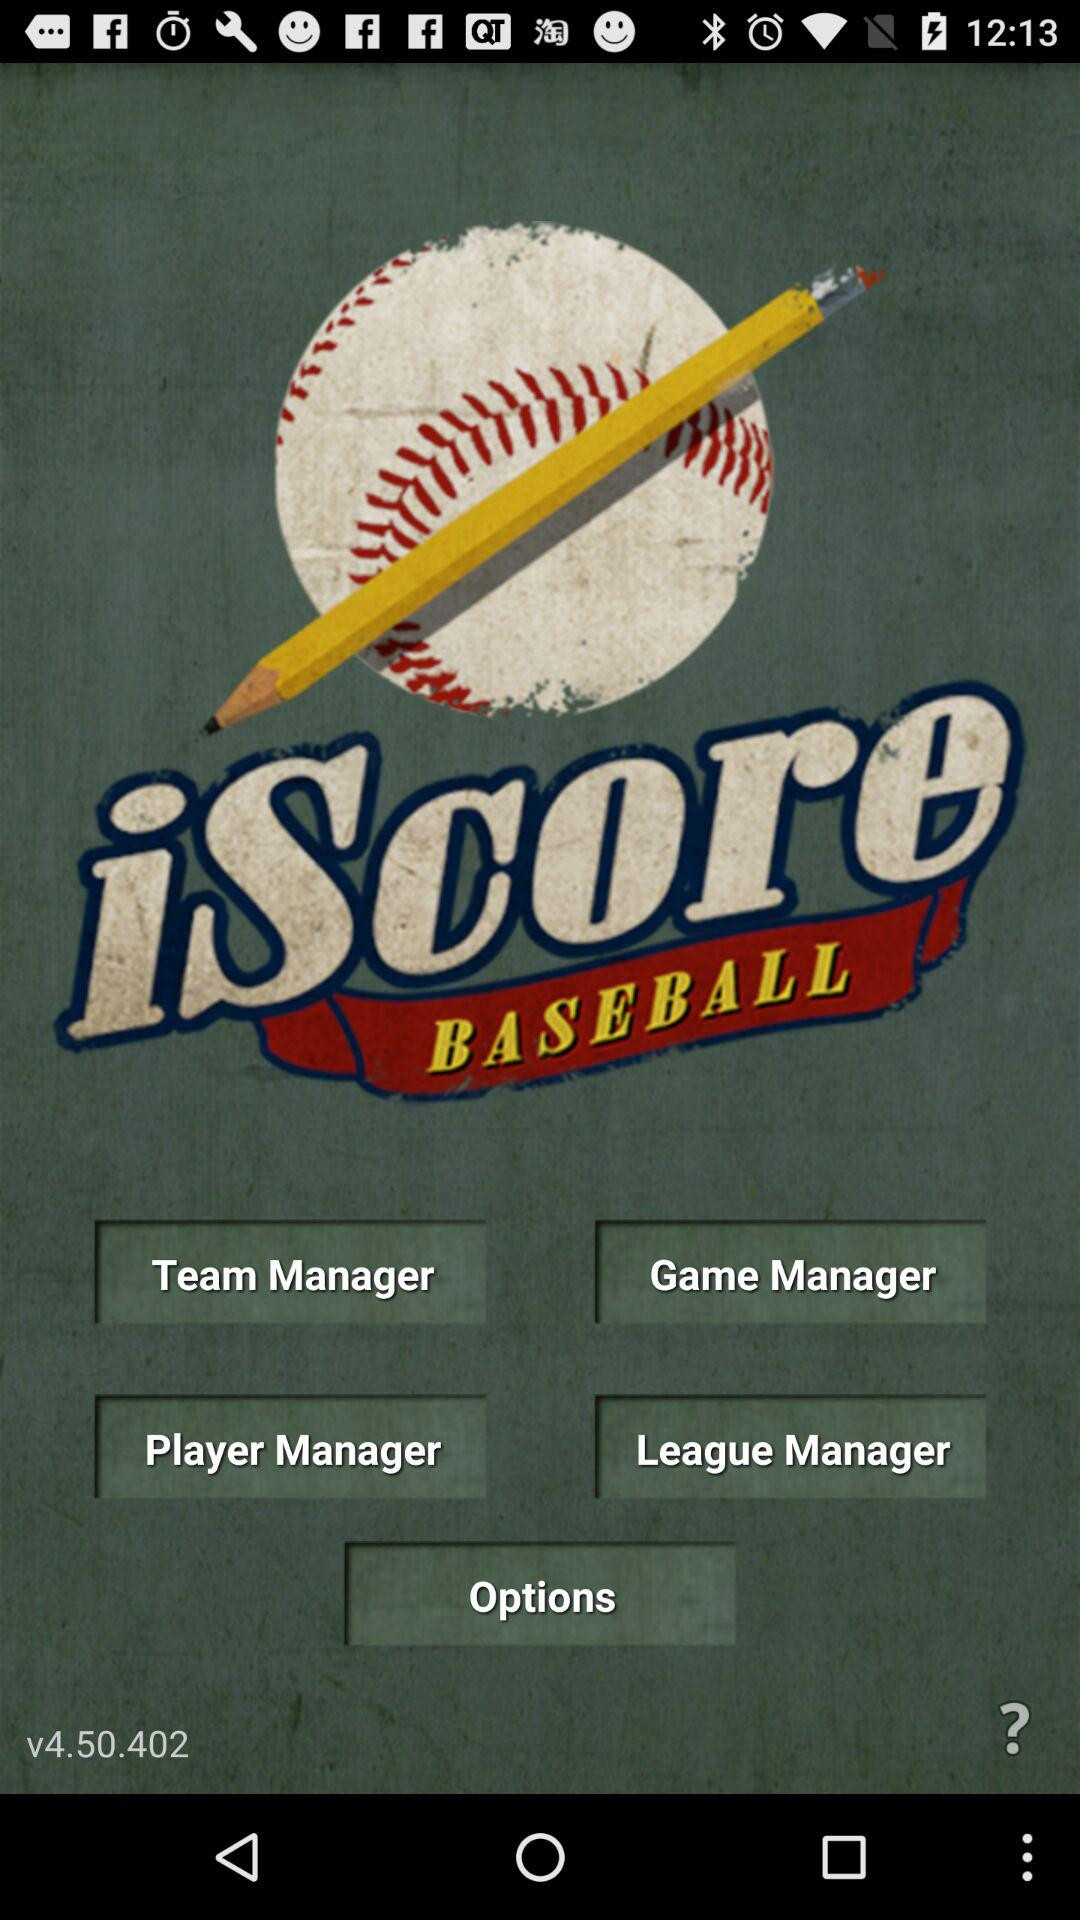What is the name of the application? The name of the application is "iScore BASEBALL". 